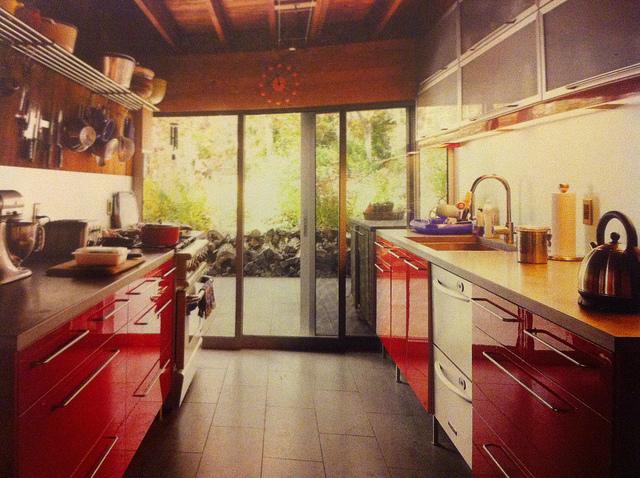Is this a living room?
Concise answer only. No. Is this kitchen tidy?
Quick response, please. Yes. Is the water running?
Quick response, please. No. 